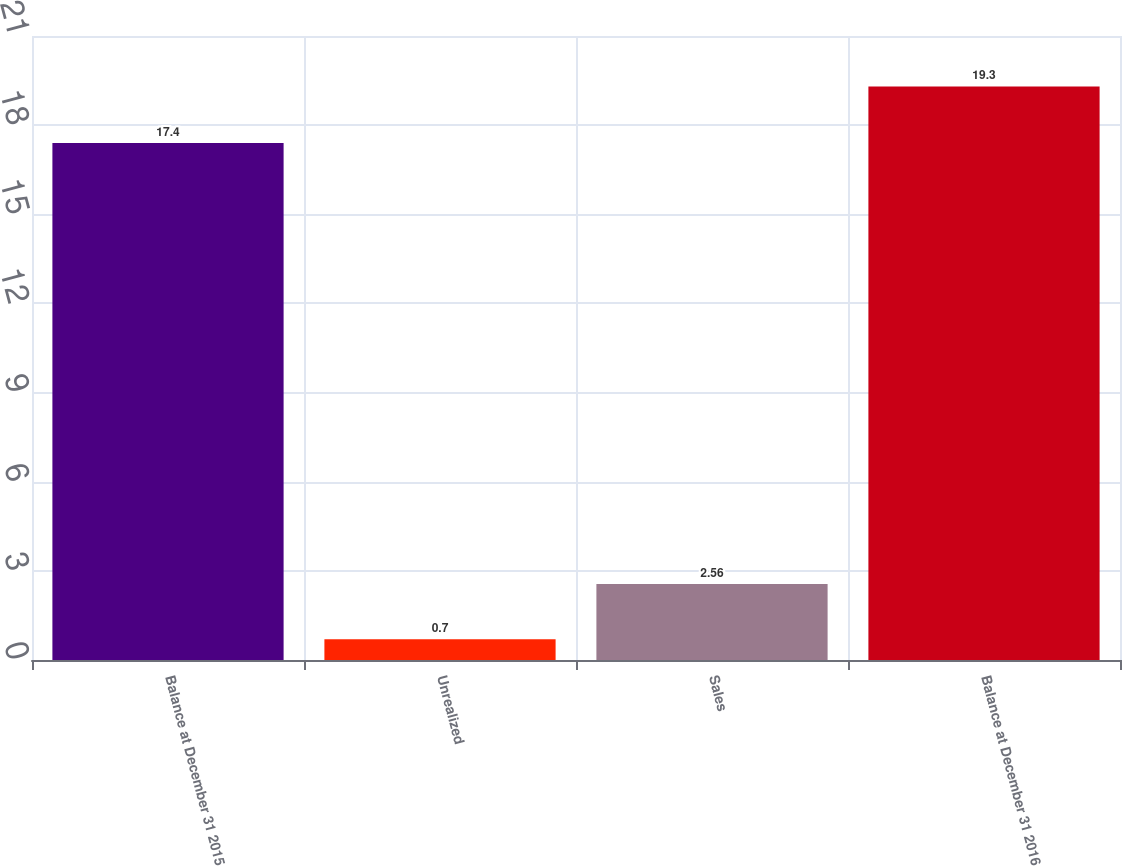<chart> <loc_0><loc_0><loc_500><loc_500><bar_chart><fcel>Balance at December 31 2015<fcel>Unrealized<fcel>Sales<fcel>Balance at December 31 2016<nl><fcel>17.4<fcel>0.7<fcel>2.56<fcel>19.3<nl></chart> 